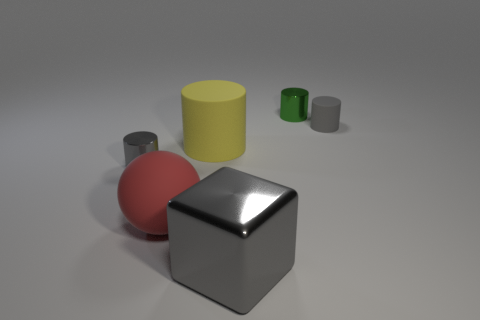There is a tiny cylinder left of the cube; what material is it?
Make the answer very short. Metal. Does the small matte object have the same shape as the tiny shiny object behind the gray matte cylinder?
Keep it short and to the point. Yes. Are there more big objects than large metal blocks?
Give a very brief answer. Yes. Are there any other things that are the same color as the shiny block?
Your response must be concise. Yes. There is a large object that is the same material as the tiny green object; what is its shape?
Make the answer very short. Cube. What is the material of the small gray thing behind the shiny cylinder on the left side of the large yellow thing?
Provide a short and direct response. Rubber. Does the gray thing left of the red sphere have the same shape as the big gray metallic thing?
Offer a terse response. No. Is the number of gray metallic objects that are left of the red sphere greater than the number of tiny purple matte cubes?
Your answer should be compact. Yes. The shiny object that is the same color as the big shiny cube is what shape?
Provide a succinct answer. Cylinder. How many blocks are red rubber things or big things?
Your answer should be very brief. 1. 